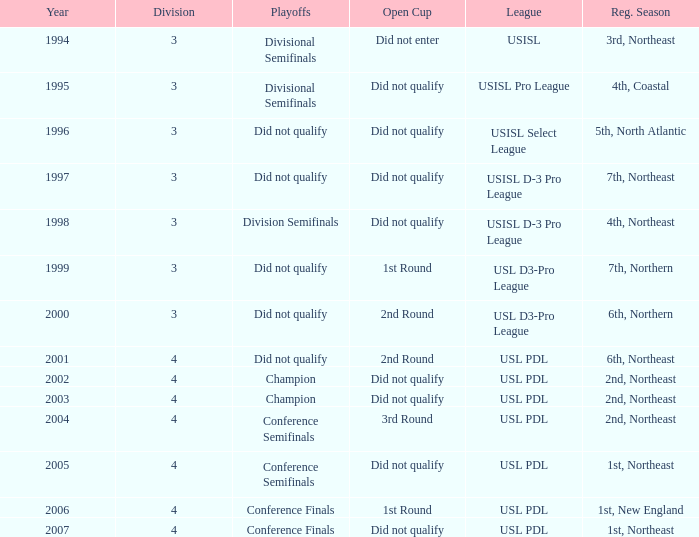Mame the reg season for 2001 6th, Northeast. 